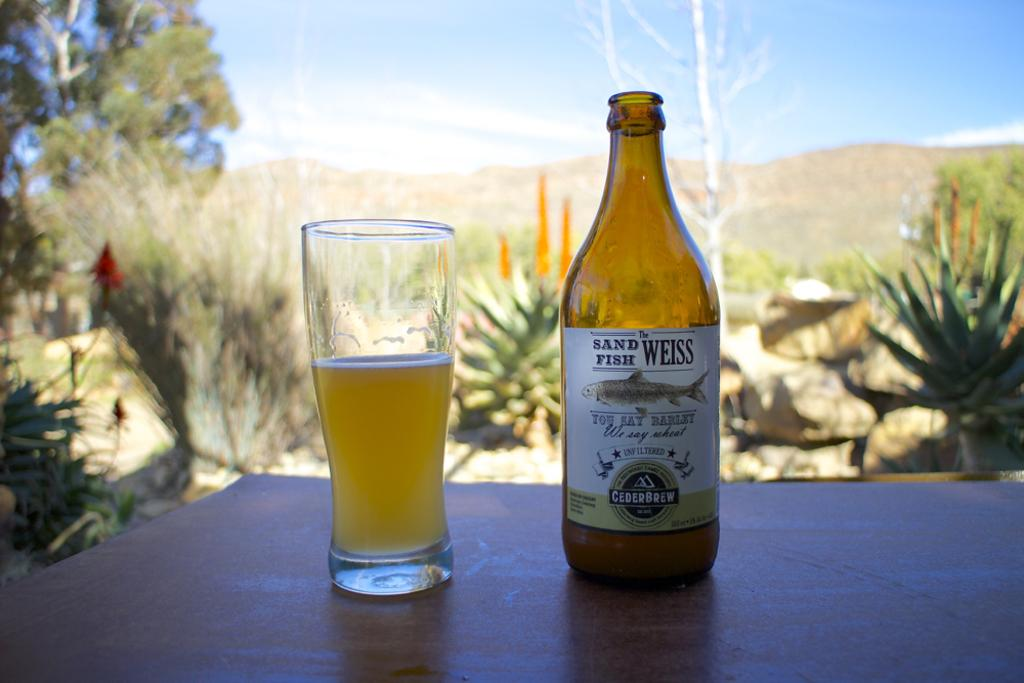What piece of furniture can be seen in the image? There is a table in the image. What objects are on the table? A bottle and a glass are present on the table. What can be seen on the left side of the image? There is a tree on the left side of the image. What type of request can be seen on the table in the image? There is no request present on the table in the image. What emotion is the tree on the left side of the image expressing? Trees do not express emotions, so it is not possible to determine the emotion of the tree in the image. 